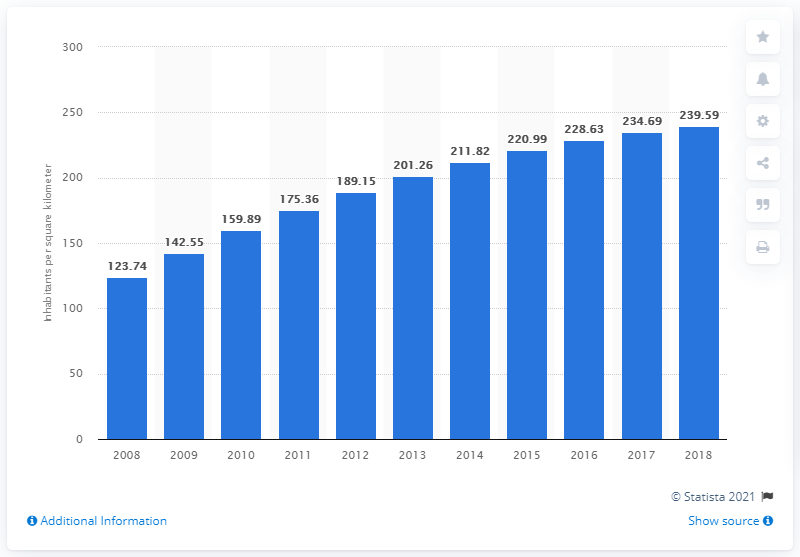Mention a couple of crucial points in this snapshot. In 2018, the population density in Qatar was 239.59 people per square kilometer. 